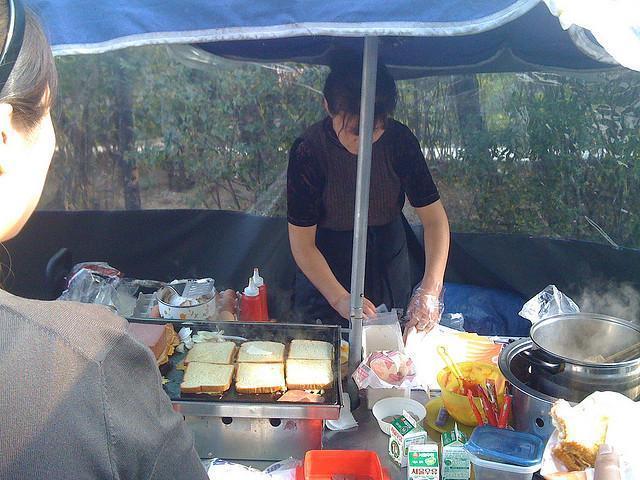How many people are there?
Give a very brief answer. 2. How many bowls are there?
Give a very brief answer. 3. 